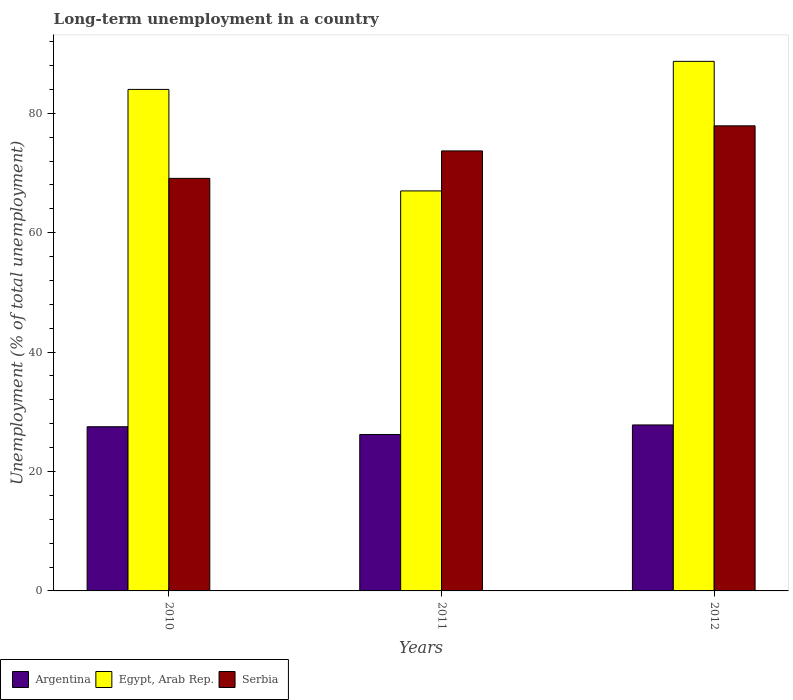How many different coloured bars are there?
Offer a very short reply. 3. Are the number of bars per tick equal to the number of legend labels?
Your response must be concise. Yes. Are the number of bars on each tick of the X-axis equal?
Make the answer very short. Yes. How many bars are there on the 3rd tick from the left?
Make the answer very short. 3. What is the label of the 3rd group of bars from the left?
Keep it short and to the point. 2012. In how many cases, is the number of bars for a given year not equal to the number of legend labels?
Ensure brevity in your answer.  0. What is the percentage of long-term unemployed population in Serbia in 2011?
Provide a succinct answer. 73.7. Across all years, what is the maximum percentage of long-term unemployed population in Egypt, Arab Rep.?
Keep it short and to the point. 88.7. Across all years, what is the minimum percentage of long-term unemployed population in Argentina?
Keep it short and to the point. 26.2. In which year was the percentage of long-term unemployed population in Serbia maximum?
Offer a very short reply. 2012. What is the total percentage of long-term unemployed population in Egypt, Arab Rep. in the graph?
Your response must be concise. 239.7. What is the difference between the percentage of long-term unemployed population in Egypt, Arab Rep. in 2010 and that in 2011?
Give a very brief answer. 17. What is the difference between the percentage of long-term unemployed population in Serbia in 2011 and the percentage of long-term unemployed population in Argentina in 2010?
Your answer should be very brief. 46.2. What is the average percentage of long-term unemployed population in Argentina per year?
Make the answer very short. 27.17. In the year 2010, what is the difference between the percentage of long-term unemployed population in Serbia and percentage of long-term unemployed population in Egypt, Arab Rep.?
Offer a terse response. -14.9. What is the ratio of the percentage of long-term unemployed population in Argentina in 2011 to that in 2012?
Your answer should be very brief. 0.94. Is the percentage of long-term unemployed population in Serbia in 2011 less than that in 2012?
Provide a succinct answer. Yes. Is the difference between the percentage of long-term unemployed population in Serbia in 2010 and 2012 greater than the difference between the percentage of long-term unemployed population in Egypt, Arab Rep. in 2010 and 2012?
Provide a succinct answer. No. What is the difference between the highest and the second highest percentage of long-term unemployed population in Argentina?
Provide a succinct answer. 0.3. What is the difference between the highest and the lowest percentage of long-term unemployed population in Argentina?
Offer a very short reply. 1.6. In how many years, is the percentage of long-term unemployed population in Egypt, Arab Rep. greater than the average percentage of long-term unemployed population in Egypt, Arab Rep. taken over all years?
Provide a succinct answer. 2. What does the 1st bar from the left in 2011 represents?
Offer a terse response. Argentina. What does the 1st bar from the right in 2011 represents?
Keep it short and to the point. Serbia. Is it the case that in every year, the sum of the percentage of long-term unemployed population in Serbia and percentage of long-term unemployed population in Argentina is greater than the percentage of long-term unemployed population in Egypt, Arab Rep.?
Give a very brief answer. Yes. How many bars are there?
Ensure brevity in your answer.  9. Are all the bars in the graph horizontal?
Ensure brevity in your answer.  No. Are the values on the major ticks of Y-axis written in scientific E-notation?
Your answer should be very brief. No. Does the graph contain any zero values?
Make the answer very short. No. Where does the legend appear in the graph?
Make the answer very short. Bottom left. How are the legend labels stacked?
Provide a succinct answer. Horizontal. What is the title of the graph?
Ensure brevity in your answer.  Long-term unemployment in a country. What is the label or title of the X-axis?
Make the answer very short. Years. What is the label or title of the Y-axis?
Make the answer very short. Unemployment (% of total unemployment). What is the Unemployment (% of total unemployment) of Argentina in 2010?
Make the answer very short. 27.5. What is the Unemployment (% of total unemployment) in Egypt, Arab Rep. in 2010?
Offer a very short reply. 84. What is the Unemployment (% of total unemployment) of Serbia in 2010?
Your answer should be compact. 69.1. What is the Unemployment (% of total unemployment) in Argentina in 2011?
Offer a terse response. 26.2. What is the Unemployment (% of total unemployment) in Egypt, Arab Rep. in 2011?
Your response must be concise. 67. What is the Unemployment (% of total unemployment) in Serbia in 2011?
Make the answer very short. 73.7. What is the Unemployment (% of total unemployment) in Argentina in 2012?
Provide a short and direct response. 27.8. What is the Unemployment (% of total unemployment) in Egypt, Arab Rep. in 2012?
Your answer should be very brief. 88.7. What is the Unemployment (% of total unemployment) of Serbia in 2012?
Provide a short and direct response. 77.9. Across all years, what is the maximum Unemployment (% of total unemployment) in Argentina?
Your answer should be compact. 27.8. Across all years, what is the maximum Unemployment (% of total unemployment) of Egypt, Arab Rep.?
Offer a very short reply. 88.7. Across all years, what is the maximum Unemployment (% of total unemployment) in Serbia?
Ensure brevity in your answer.  77.9. Across all years, what is the minimum Unemployment (% of total unemployment) in Argentina?
Provide a succinct answer. 26.2. Across all years, what is the minimum Unemployment (% of total unemployment) in Egypt, Arab Rep.?
Offer a terse response. 67. Across all years, what is the minimum Unemployment (% of total unemployment) in Serbia?
Provide a short and direct response. 69.1. What is the total Unemployment (% of total unemployment) of Argentina in the graph?
Make the answer very short. 81.5. What is the total Unemployment (% of total unemployment) of Egypt, Arab Rep. in the graph?
Ensure brevity in your answer.  239.7. What is the total Unemployment (% of total unemployment) of Serbia in the graph?
Give a very brief answer. 220.7. What is the difference between the Unemployment (% of total unemployment) of Egypt, Arab Rep. in 2010 and that in 2011?
Your answer should be very brief. 17. What is the difference between the Unemployment (% of total unemployment) in Egypt, Arab Rep. in 2010 and that in 2012?
Keep it short and to the point. -4.7. What is the difference between the Unemployment (% of total unemployment) of Argentina in 2011 and that in 2012?
Offer a terse response. -1.6. What is the difference between the Unemployment (% of total unemployment) of Egypt, Arab Rep. in 2011 and that in 2012?
Your answer should be compact. -21.7. What is the difference between the Unemployment (% of total unemployment) in Argentina in 2010 and the Unemployment (% of total unemployment) in Egypt, Arab Rep. in 2011?
Offer a very short reply. -39.5. What is the difference between the Unemployment (% of total unemployment) in Argentina in 2010 and the Unemployment (% of total unemployment) in Serbia in 2011?
Offer a terse response. -46.2. What is the difference between the Unemployment (% of total unemployment) of Egypt, Arab Rep. in 2010 and the Unemployment (% of total unemployment) of Serbia in 2011?
Keep it short and to the point. 10.3. What is the difference between the Unemployment (% of total unemployment) of Argentina in 2010 and the Unemployment (% of total unemployment) of Egypt, Arab Rep. in 2012?
Your response must be concise. -61.2. What is the difference between the Unemployment (% of total unemployment) in Argentina in 2010 and the Unemployment (% of total unemployment) in Serbia in 2012?
Provide a short and direct response. -50.4. What is the difference between the Unemployment (% of total unemployment) in Argentina in 2011 and the Unemployment (% of total unemployment) in Egypt, Arab Rep. in 2012?
Offer a very short reply. -62.5. What is the difference between the Unemployment (% of total unemployment) of Argentina in 2011 and the Unemployment (% of total unemployment) of Serbia in 2012?
Provide a succinct answer. -51.7. What is the average Unemployment (% of total unemployment) in Argentina per year?
Offer a very short reply. 27.17. What is the average Unemployment (% of total unemployment) in Egypt, Arab Rep. per year?
Your answer should be compact. 79.9. What is the average Unemployment (% of total unemployment) of Serbia per year?
Your response must be concise. 73.57. In the year 2010, what is the difference between the Unemployment (% of total unemployment) in Argentina and Unemployment (% of total unemployment) in Egypt, Arab Rep.?
Offer a very short reply. -56.5. In the year 2010, what is the difference between the Unemployment (% of total unemployment) of Argentina and Unemployment (% of total unemployment) of Serbia?
Keep it short and to the point. -41.6. In the year 2010, what is the difference between the Unemployment (% of total unemployment) in Egypt, Arab Rep. and Unemployment (% of total unemployment) in Serbia?
Your answer should be very brief. 14.9. In the year 2011, what is the difference between the Unemployment (% of total unemployment) of Argentina and Unemployment (% of total unemployment) of Egypt, Arab Rep.?
Offer a very short reply. -40.8. In the year 2011, what is the difference between the Unemployment (% of total unemployment) of Argentina and Unemployment (% of total unemployment) of Serbia?
Give a very brief answer. -47.5. In the year 2012, what is the difference between the Unemployment (% of total unemployment) of Argentina and Unemployment (% of total unemployment) of Egypt, Arab Rep.?
Provide a short and direct response. -60.9. In the year 2012, what is the difference between the Unemployment (% of total unemployment) in Argentina and Unemployment (% of total unemployment) in Serbia?
Keep it short and to the point. -50.1. What is the ratio of the Unemployment (% of total unemployment) of Argentina in 2010 to that in 2011?
Ensure brevity in your answer.  1.05. What is the ratio of the Unemployment (% of total unemployment) of Egypt, Arab Rep. in 2010 to that in 2011?
Make the answer very short. 1.25. What is the ratio of the Unemployment (% of total unemployment) of Serbia in 2010 to that in 2011?
Offer a terse response. 0.94. What is the ratio of the Unemployment (% of total unemployment) of Egypt, Arab Rep. in 2010 to that in 2012?
Offer a terse response. 0.95. What is the ratio of the Unemployment (% of total unemployment) in Serbia in 2010 to that in 2012?
Your response must be concise. 0.89. What is the ratio of the Unemployment (% of total unemployment) of Argentina in 2011 to that in 2012?
Offer a very short reply. 0.94. What is the ratio of the Unemployment (% of total unemployment) of Egypt, Arab Rep. in 2011 to that in 2012?
Give a very brief answer. 0.76. What is the ratio of the Unemployment (% of total unemployment) of Serbia in 2011 to that in 2012?
Ensure brevity in your answer.  0.95. What is the difference between the highest and the second highest Unemployment (% of total unemployment) of Argentina?
Keep it short and to the point. 0.3. What is the difference between the highest and the lowest Unemployment (% of total unemployment) in Egypt, Arab Rep.?
Your response must be concise. 21.7. 